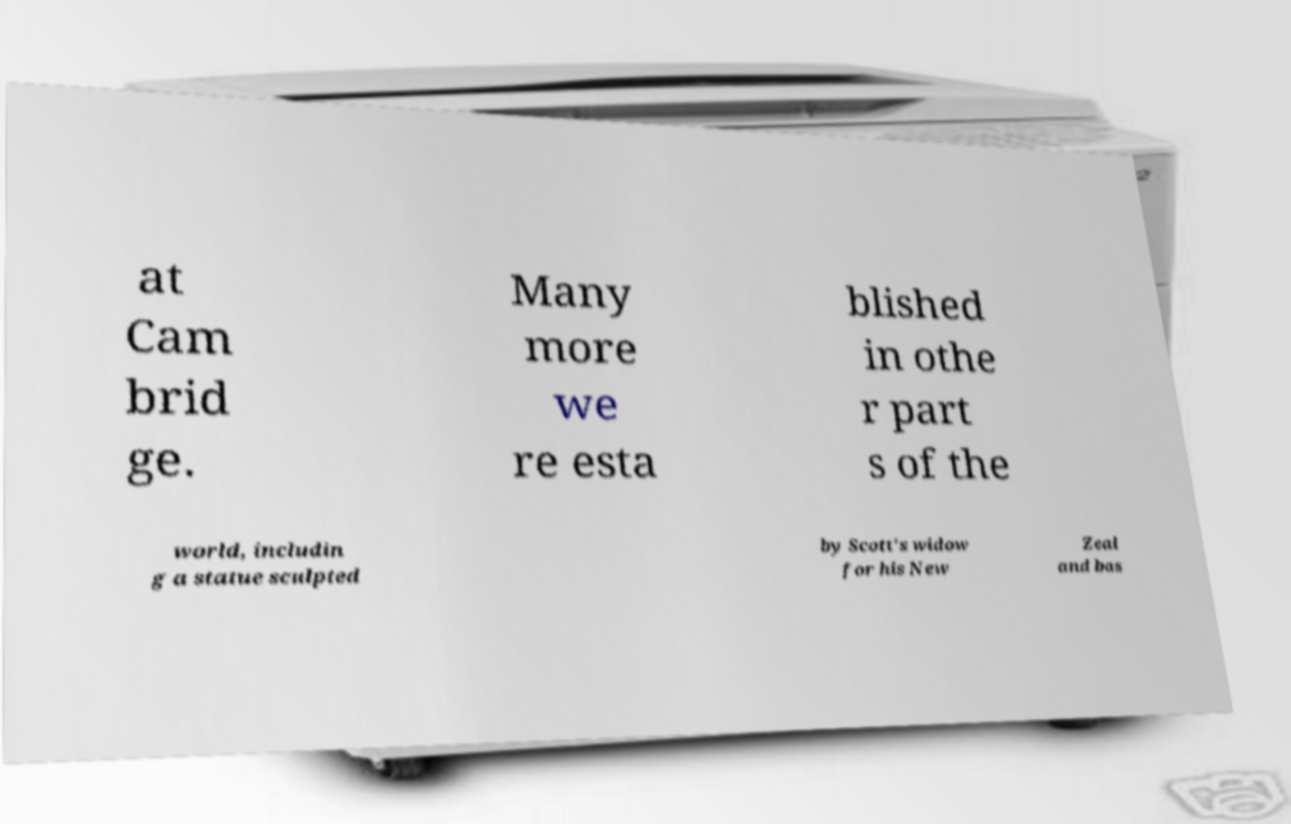For documentation purposes, I need the text within this image transcribed. Could you provide that? at Cam brid ge. Many more we re esta blished in othe r part s of the world, includin g a statue sculpted by Scott's widow for his New Zeal and bas 